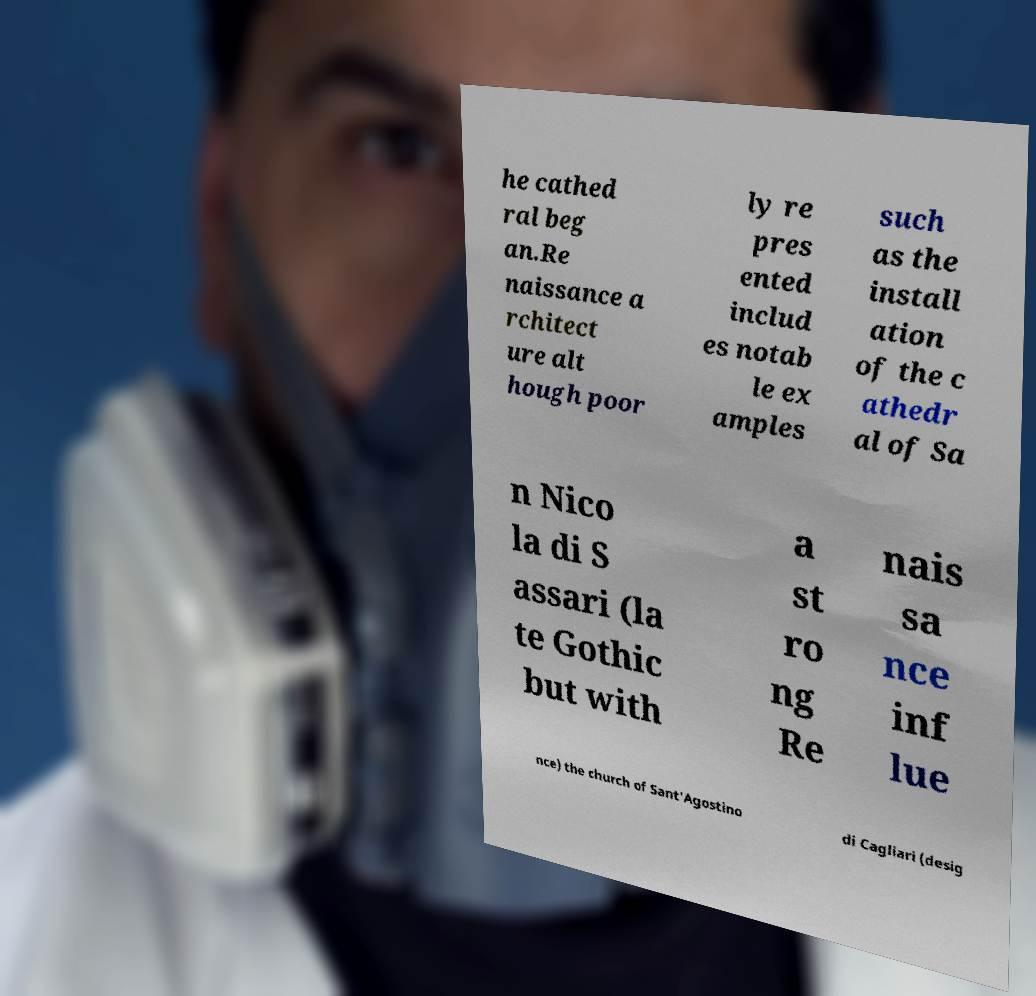For documentation purposes, I need the text within this image transcribed. Could you provide that? he cathed ral beg an.Re naissance a rchitect ure alt hough poor ly re pres ented includ es notab le ex amples such as the install ation of the c athedr al of Sa n Nico la di S assari (la te Gothic but with a st ro ng Re nais sa nce inf lue nce) the church of Sant'Agostino di Cagliari (desig 